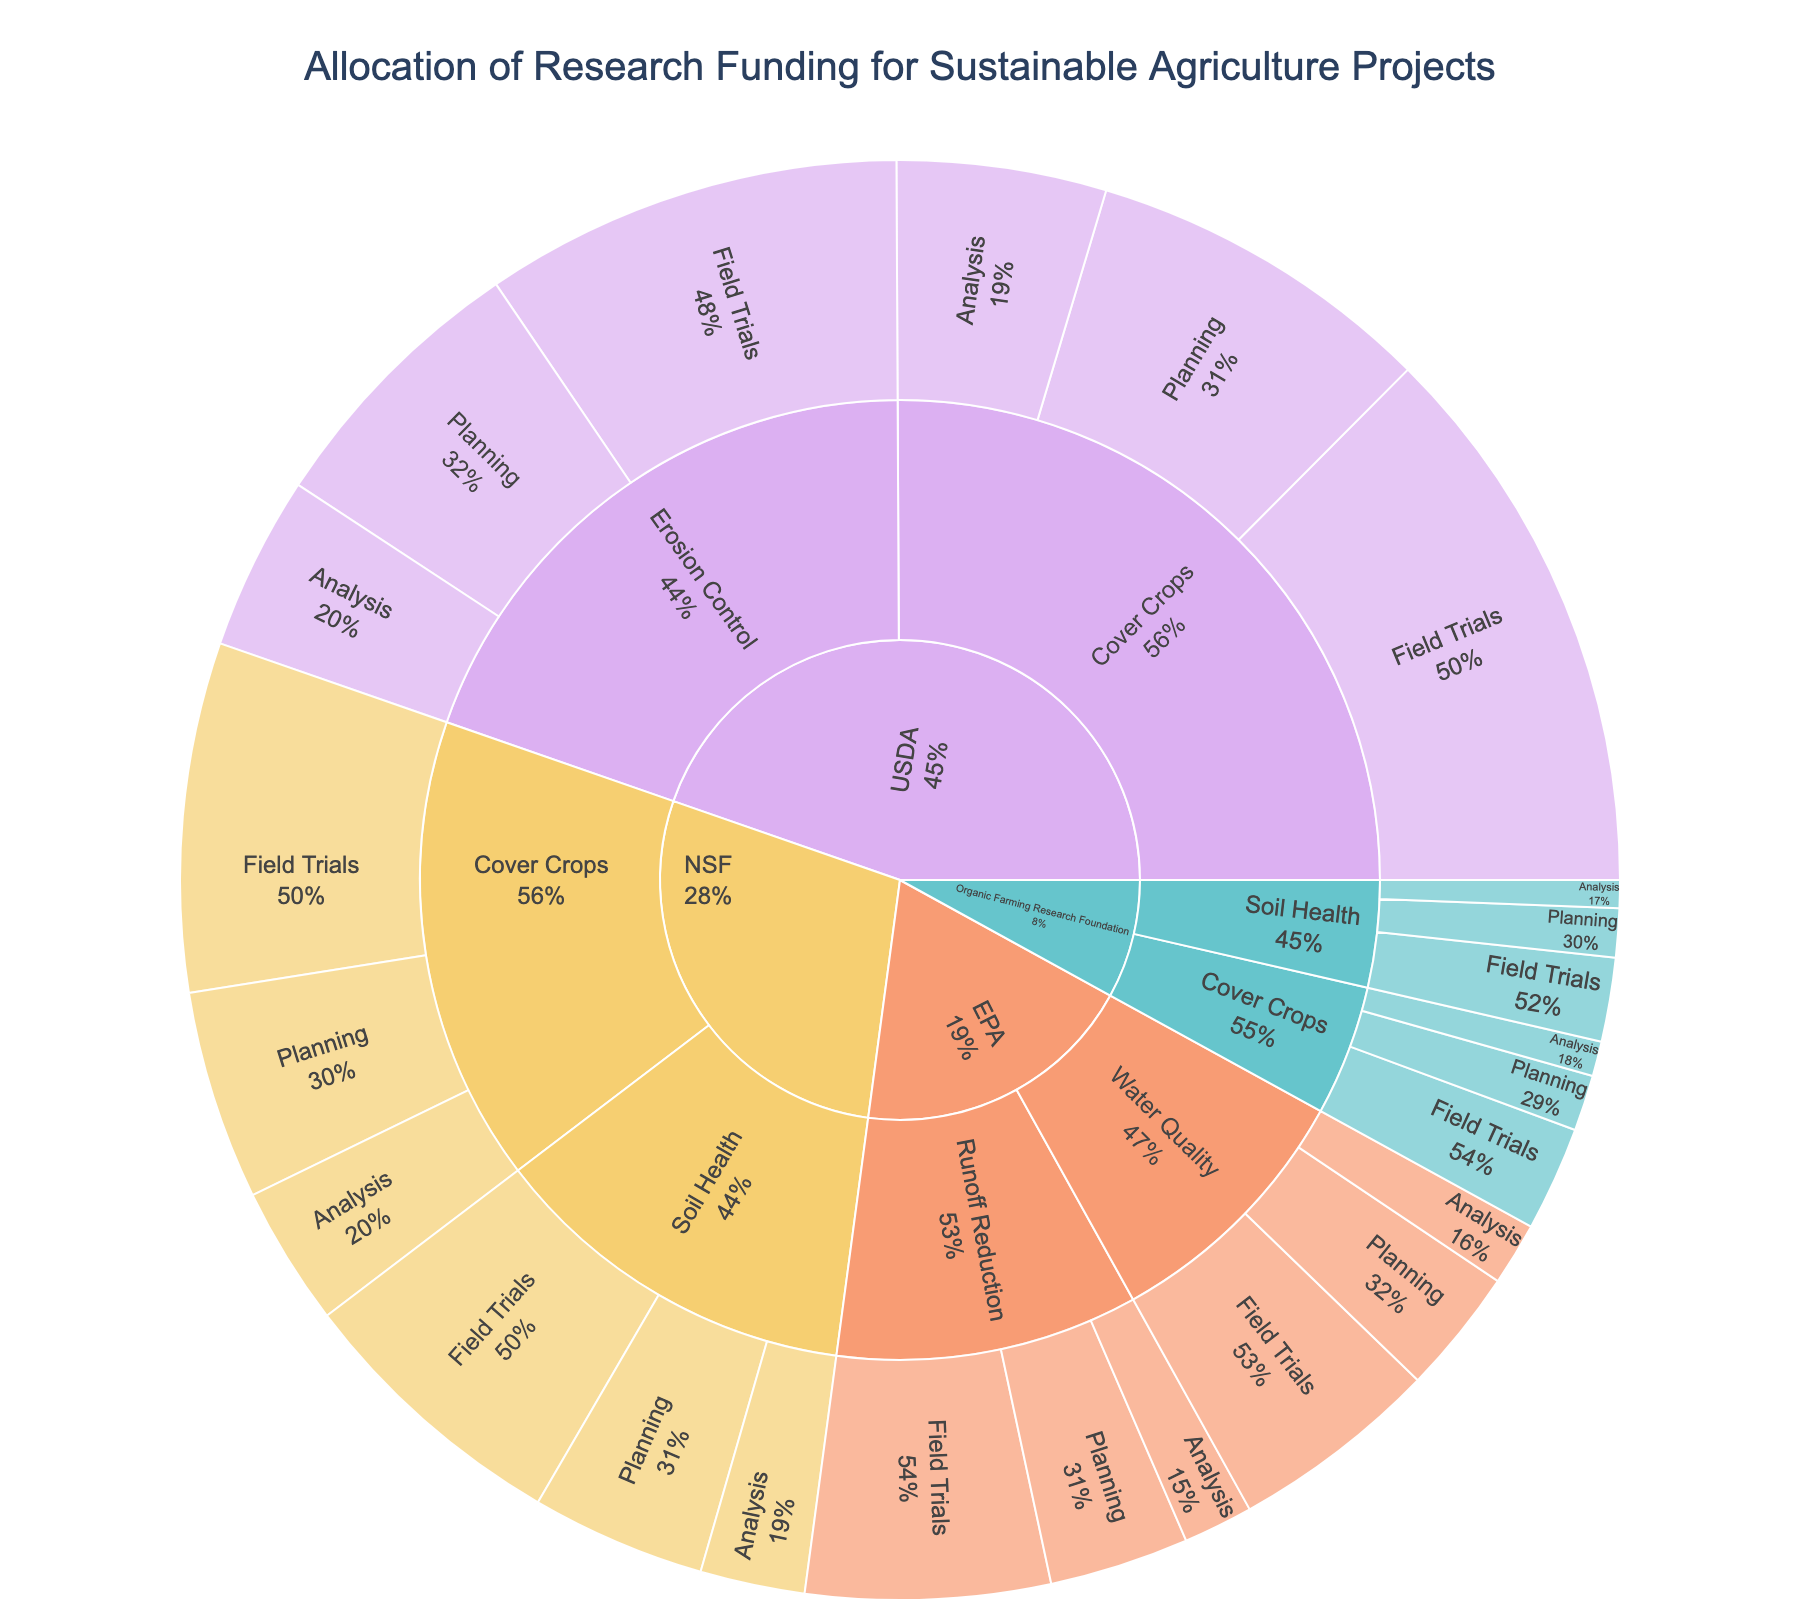What is the title of the figure? The title is displayed at the top of the figure and clearly states its purpose.
Answer: Allocation of Research Funding for Sustainable Agriculture Projects Which funding source has the highest total funding across all research focuses? Total the values for each funding source. USDA has a total of $24,500,000 (sum of all USDA values), NSF has $15,900,000, EPA has $12,700,000, and Organic Farming Research Foundation has $4,800,000.
Answer: USDA Which research focus under USDA received the most funding? Sum the values for each research focus under USDA. Cover Crops: $5,000,000 (Planning) + $8,000,000 (Field Trials) + $3,000,000 (Analysis) = $16,000,000. Erosion Control: $4,000,000 (Planning) + $6,000,000 (Field Trials) + $2,500,000 (Analysis) = $12,500,000. Therefore, Cover Crops received the most funding.
Answer: Cover Crops How much funding did EPA allocate for the Field Trials stage in total? Add the Field Trials values for EPA's research focuses. Runoff Reduction: $3,500,000 + Water Quality: $3,000,000. Therefore, the total funding is $6,500,000.
Answer: $6,500,000 Compare the total funding between Analysis stage and Planning stage for the research focus "Soil Health" under NSF. Which stage received more funding? Sum the values for each stage. Planning: $2,500,000. Analysis: $1,500,000. The Planning stage received more funding.
Answer: Planning stage Which research focus under Organic Farming Research Foundation has the least total funding? Sum the values for each research focus. Cover Crops: $800,000 (Planning) + $1,500,000 (Field Trials) + $500,000 (Analysis) = $2,800,000. Soil Health: $700,000 (Planning) + $1,200,000 (Field Trials) + $400,000 (Analysis) = $2,300,000. Therefore, Soil Health has the least total funding.
Answer: Soil Health What percentage of USDA's total funding is allocated to the Analysis stage across all research focuses? First, find the total USDA funding: $24,500,000. Next, sum the Analysis stage funding for USDA: Cover Crops ($3,000,000) + Erosion Control ($2,500,000) = $5,500,000. Then, divide Analysis stage funding by total USDA funding and multiply by 100 to get the percentage. \((5,500,000 / 24,500,000) * 100 ≈ 22.45\%\)
Answer: 22.45% Of all the implementation stages (Planning, Field Trials, Analysis), which stage has the highest funding across all funding sources? Sum the values for each stage across all funding sources. Planning: USDA ($5,000,000 + $4,000,000) + NSF ($3,000,000 + $2,500,000) + EPA ($2,000,000 + $1,800,000) + Organic Farming Research Foundation ($800,000 + $700,000) = $20,800,000. Field Trials: USDA ($8,000,000 + $6,000,000) + NSF ($5,000,000 + $4,000,000) + EPA ($3,500,000 + $3,000,000) + Organic Farming Research Foundation ($1,500,000 + $1,200,000) = $32,200,000. Analysis: USDA ($3,000,000 + $2,500,000) + NSF ($2,000,000 + $1,500,000) + EPA ($1,000,000 + $900,000) + Organic Farming Research Foundation ($500,000 + $400,000) = $11,800,000. Field Trials has the highest funding.
Answer: Field Trials 